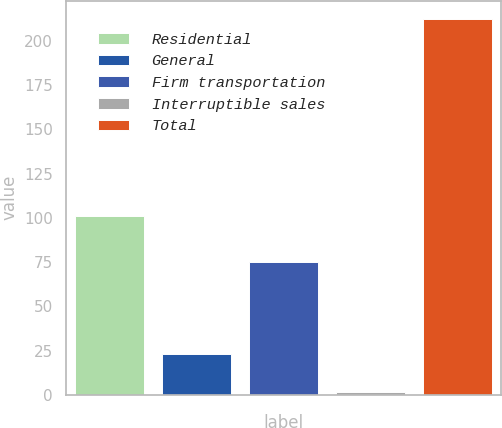Convert chart. <chart><loc_0><loc_0><loc_500><loc_500><bar_chart><fcel>Residential<fcel>General<fcel>Firm transportation<fcel>Interruptible sales<fcel>Total<nl><fcel>101<fcel>23<fcel>75<fcel>2<fcel>212<nl></chart> 